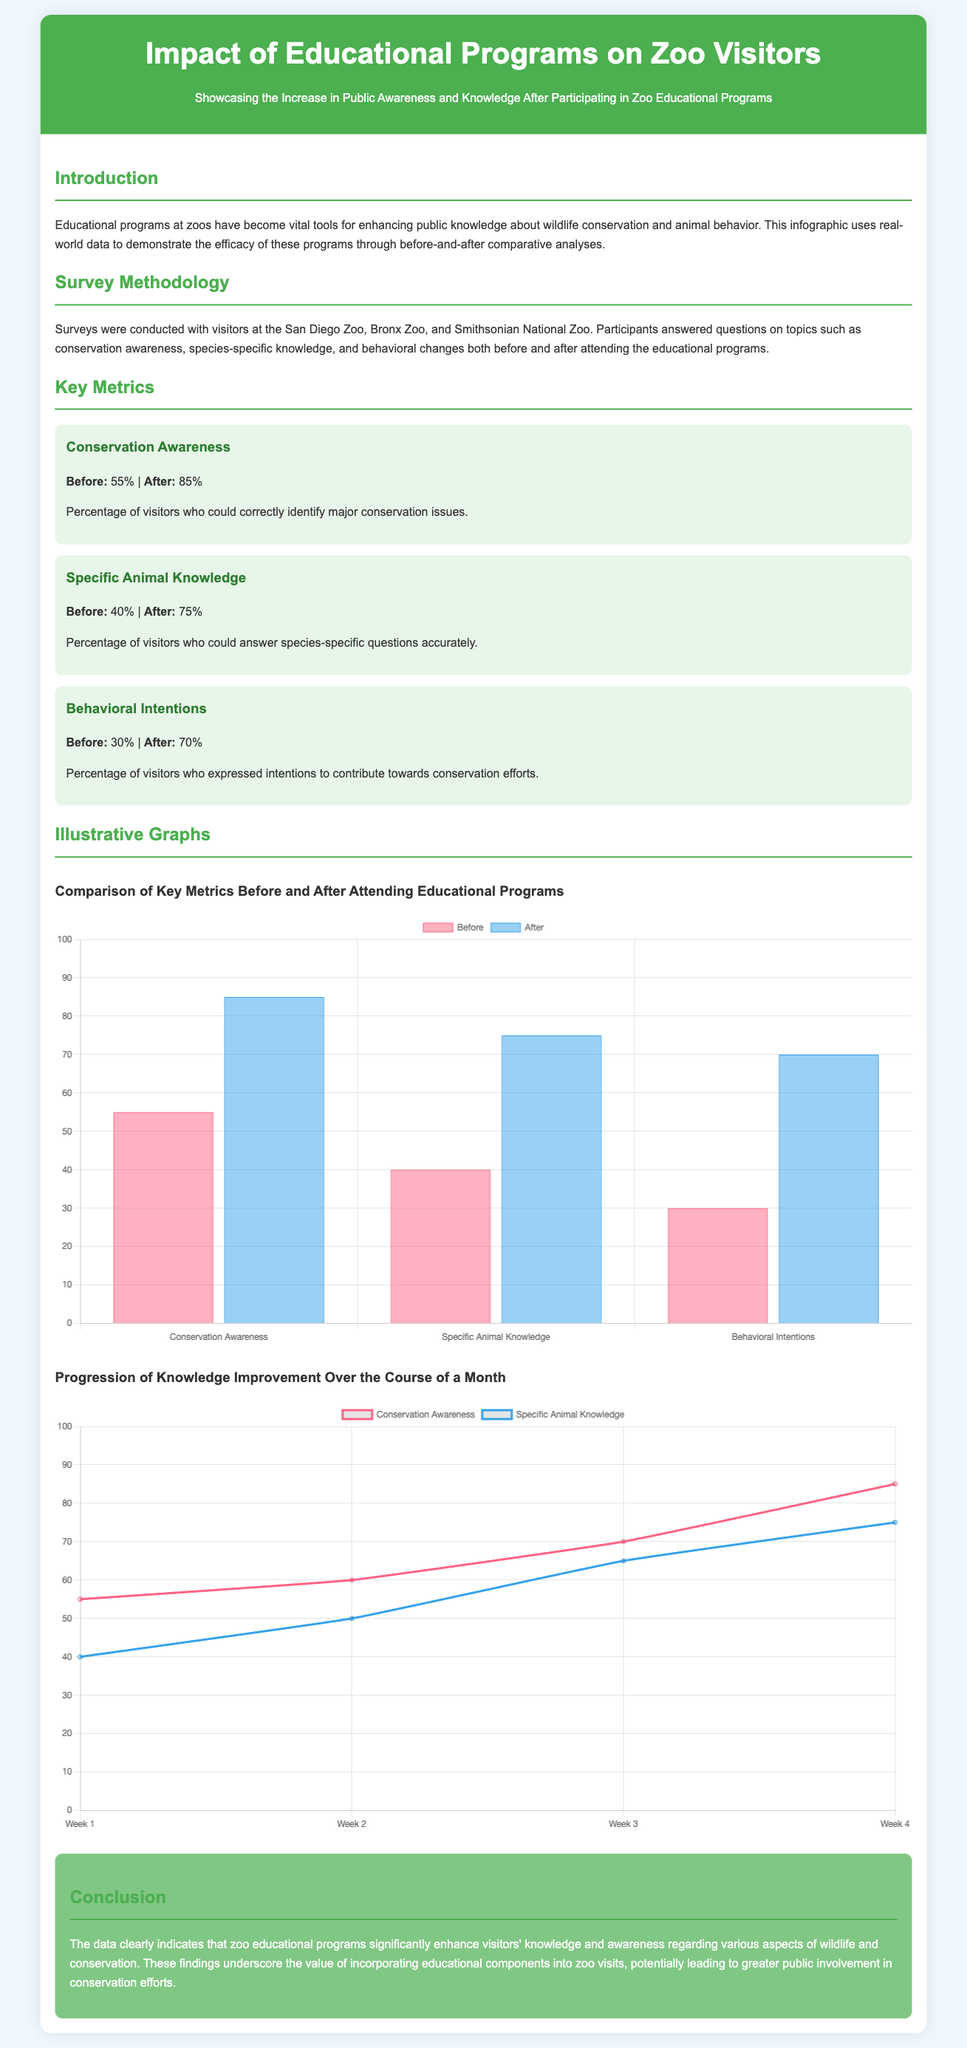what was the percentage of visitors who could identify major conservation issues before the program? The percentage of visitors who could identify major conservation issues before the program is stated under Key Metrics.
Answer: 55% what was the percentage of visitors who expressed intentions to contribute to conservation after the program? The percentage of visitors who expressed intentions to contribute to conservation after participating in the educational programs is shown in Key Metrics.
Answer: 70% how many zoos were included in the survey methodology? The survey methodology section mentions the number of zoos participating in the study.
Answer: 3 what is the color representing 'Specific Animal Knowledge' in the bar chart? The bar chart colors help identify each category, with each color linked to a specific metric.
Answer: Blue what was the knowledge percentage increase for Specific Animal Knowledge after the program? The increase in knowledge for Specific Animal Knowledge is determined by calculating the difference in percentages before and after attending the educational programs.
Answer: 35% how long was the time frame for tracking knowledge improvement in the line chart? The time frame for tracking knowledge improvement is explicitly mentioned in the chart's labeling.
Answer: 1 Month what is the highest percentage of conservation awareness achieved after the program? The highest percentage of conservation awareness achieved is listed among the results under Key Metrics.
Answer: 85% which zoo is included in the survey? The survey methodology lists specific zoos that participated in the educational program surveys.
Answer: San Diego Zoo 